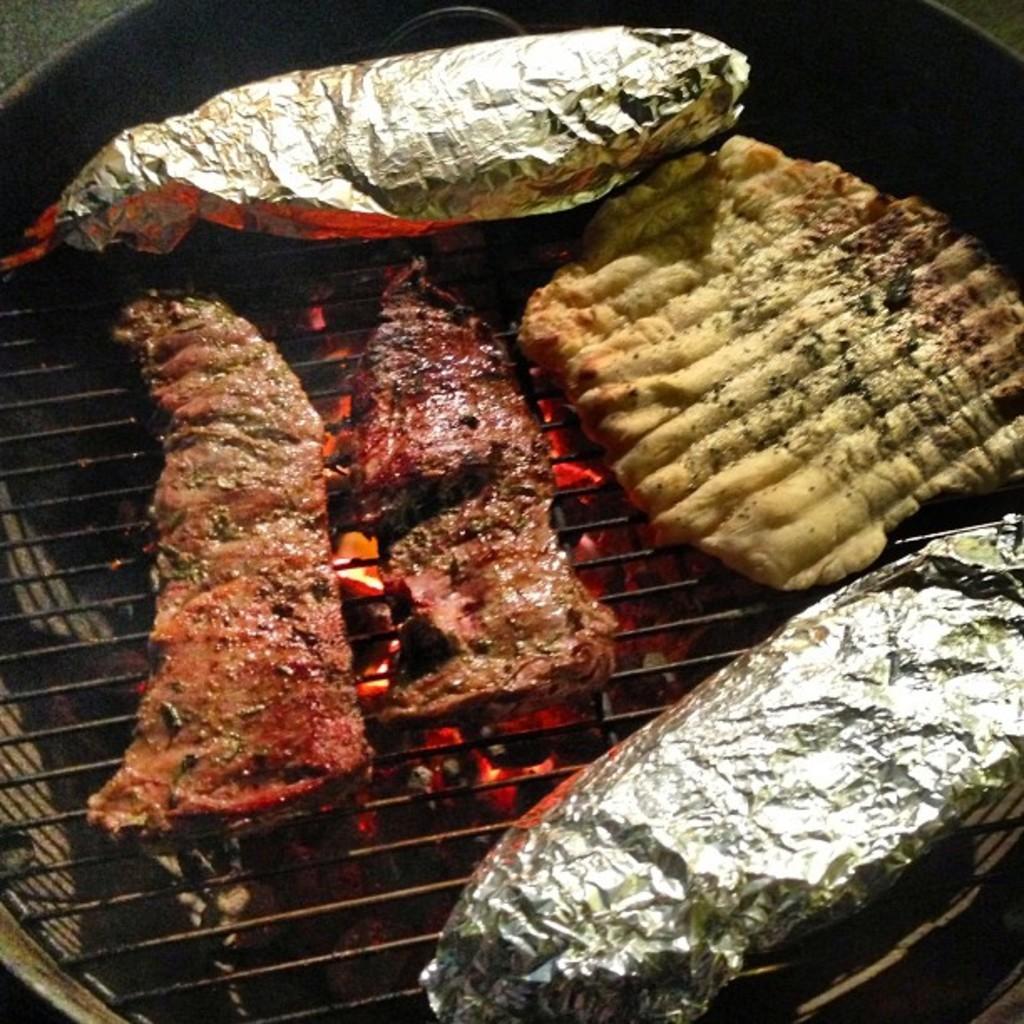How would you summarize this image in a sentence or two? In this picture we can see food items, aluminium foil placed on a grill and under this grill we can see fire. 